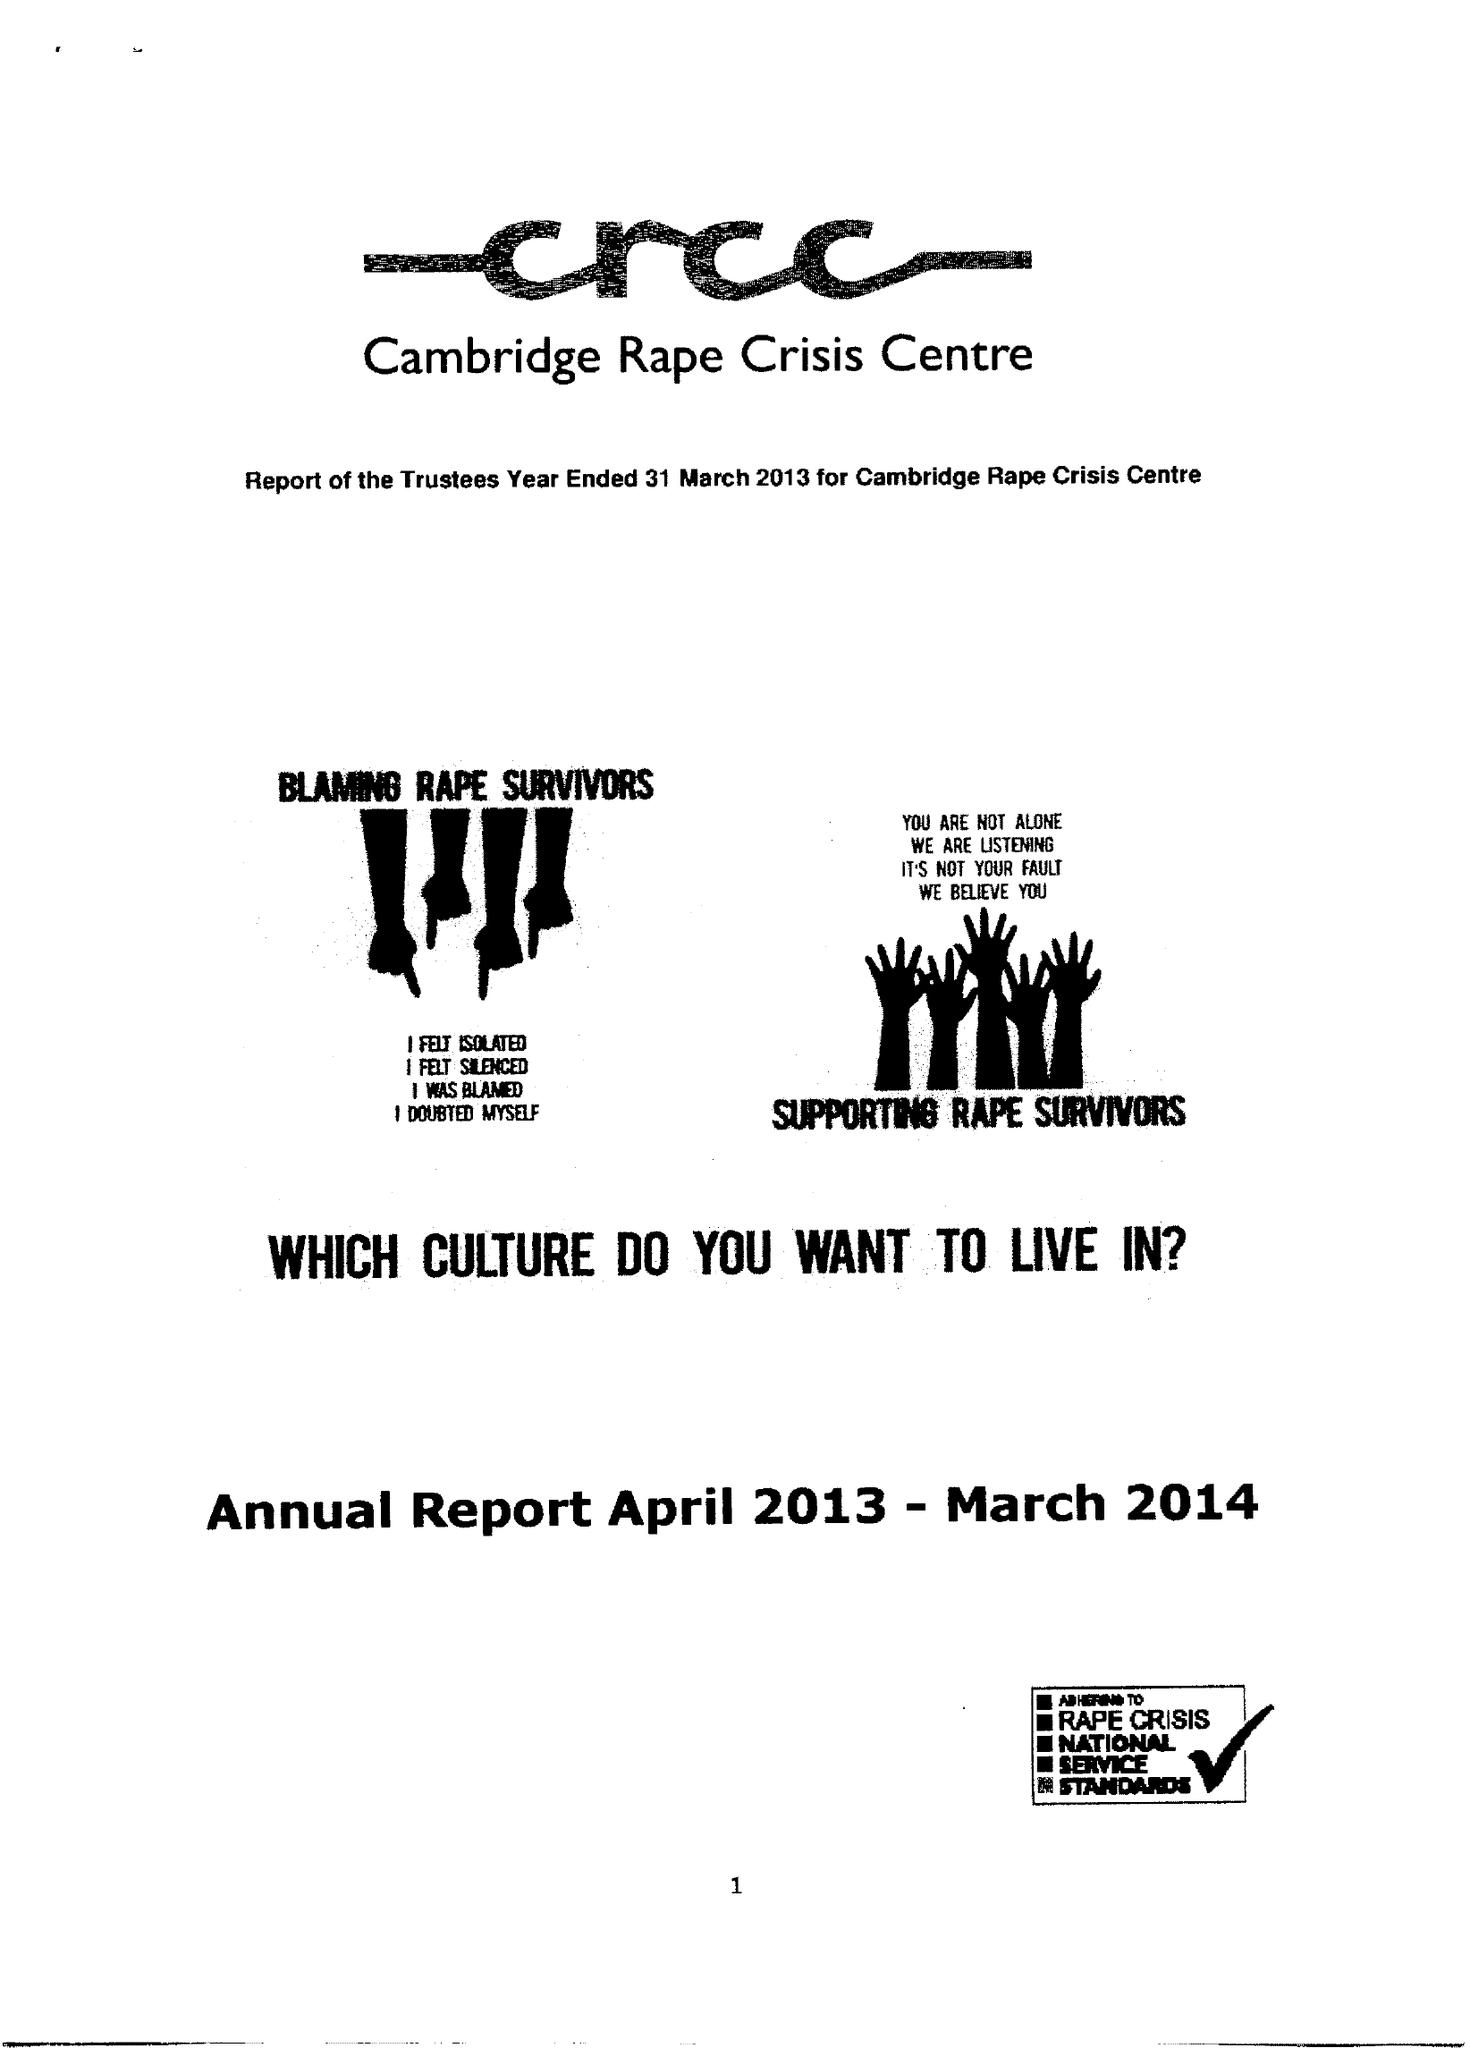What is the value for the report_date?
Answer the question using a single word or phrase. 2014-03-31 